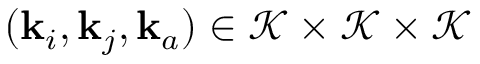Convert formula to latex. <formula><loc_0><loc_0><loc_500><loc_500>( k _ { i } , k _ { j } , k _ { a } ) \in \mathcal { K } \times \mathcal { K } \times \mathcal { K }</formula> 